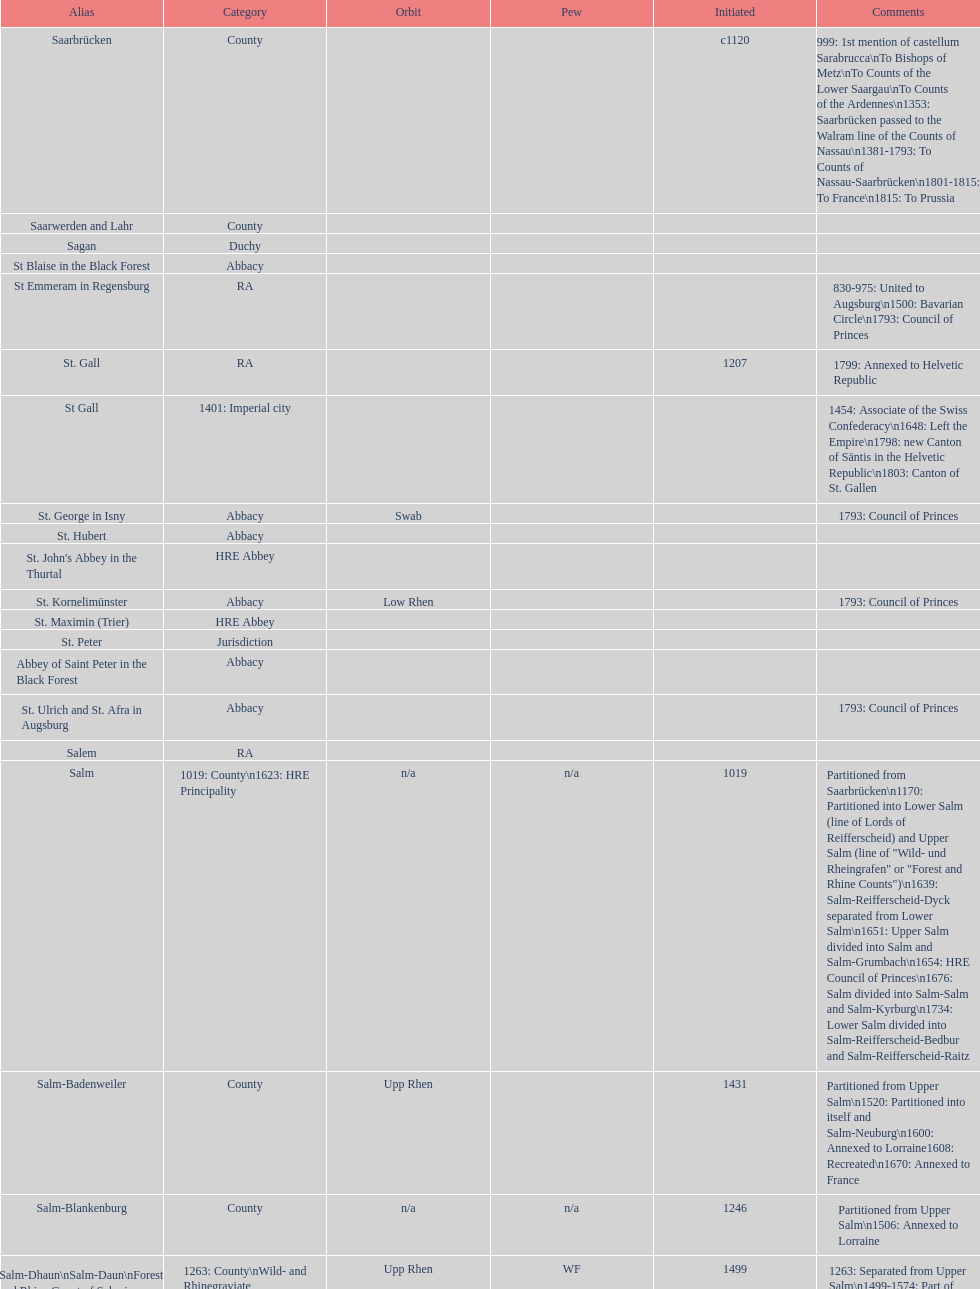Which bench is represented the most? PR. 